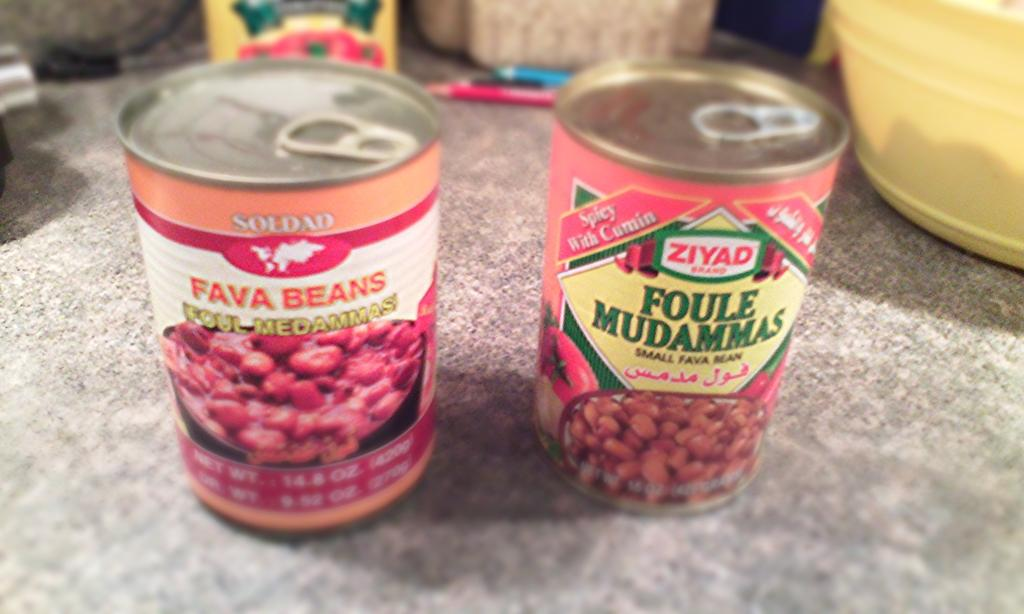Provide a one-sentence caption for the provided image. Two cans of beans sit on a table, one reading "fava beans" and the other reading "foule mudammas.". 